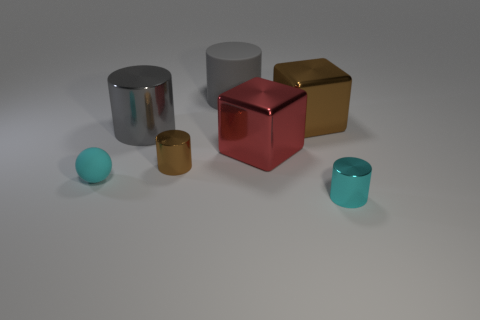Can you describe the arrangement and colors of the objects in the image? Certainly. The image depicts a variety of geometric objects with different colors and finishes. Starting from the left, there is a small turquoise rubber sphere, followed by a reflective silver cylinder. Next is a matte red cube, and to its right is a gold cube with a shiny finish. In front of these two cubes, there is a small, reflective brown metal cylinder. Finally, on the far right is a small, matte teal cup. 